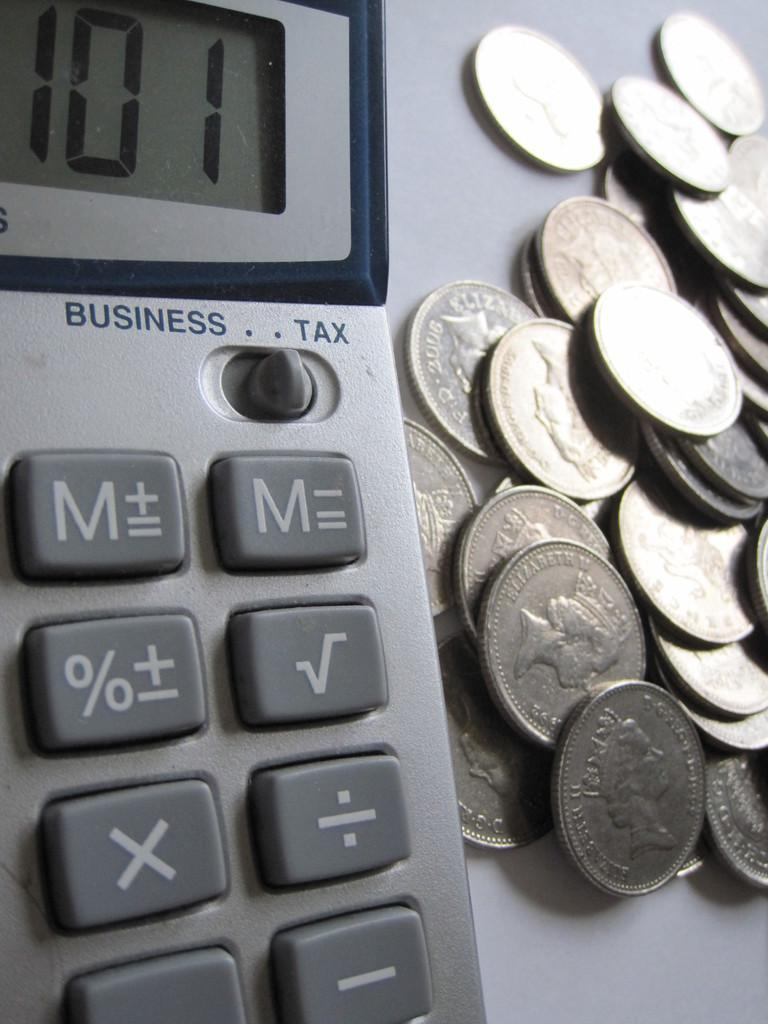<image>
Provide a brief description of the given image. A calculator that has a business or tax setting. 